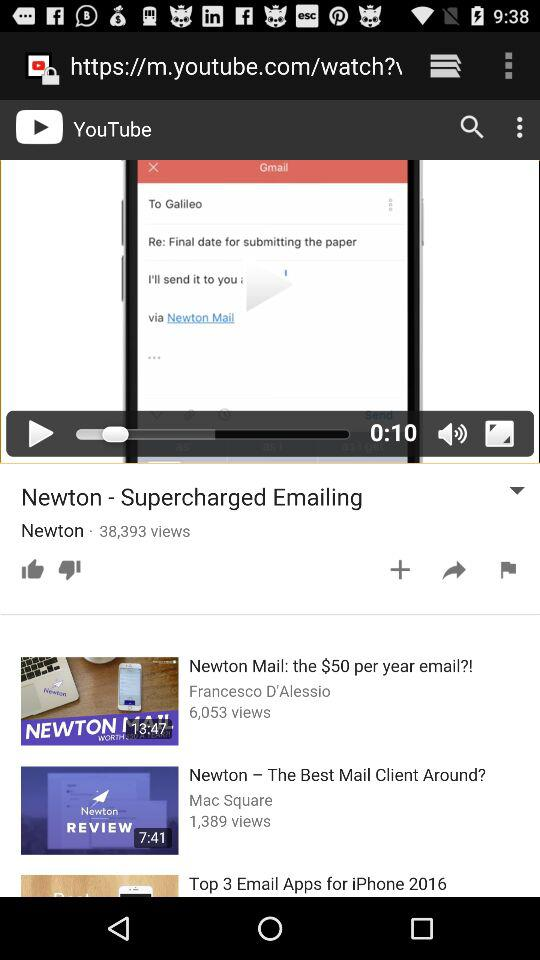How many videos have more than 5000 views?
Answer the question using a single word or phrase. 2 